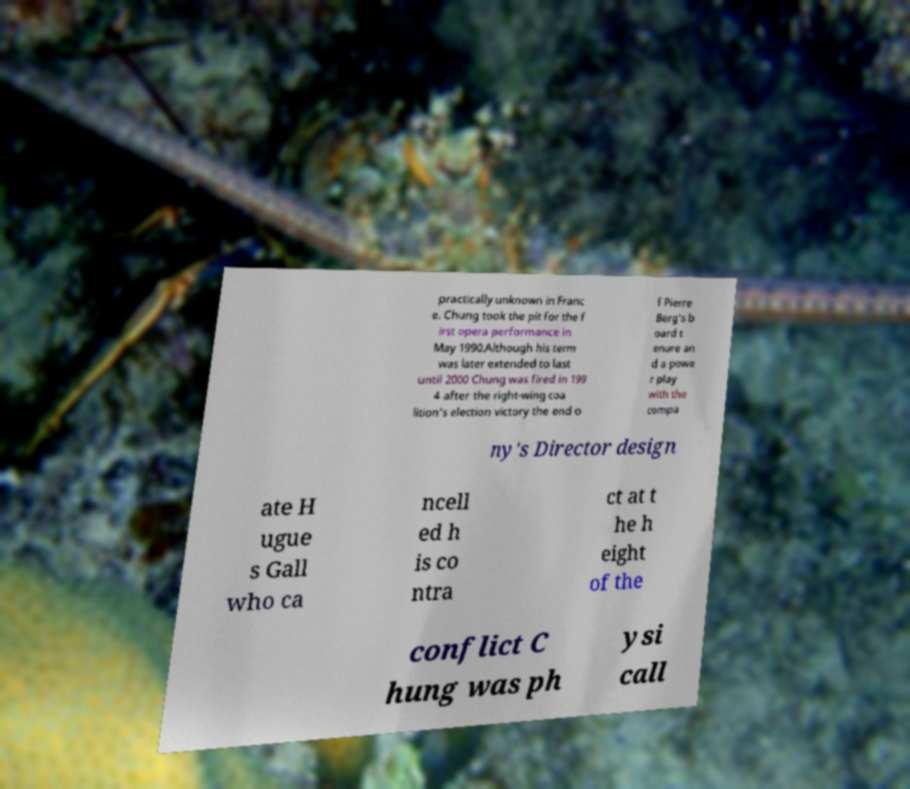Please identify and transcribe the text found in this image. practically unknown in Franc e. Chung took the pit for the f irst opera performance in May 1990.Although his term was later extended to last until 2000 Chung was fired in 199 4 after the right-wing coa lition's election victory the end o f Pierre Berg's b oard t enure an d a powe r play with the compa ny's Director design ate H ugue s Gall who ca ncell ed h is co ntra ct at t he h eight of the conflict C hung was ph ysi call 